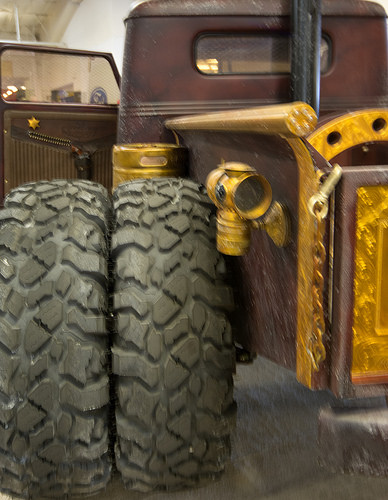<image>
Is there a tire on the truck? Yes. Looking at the image, I can see the tire is positioned on top of the truck, with the truck providing support. 